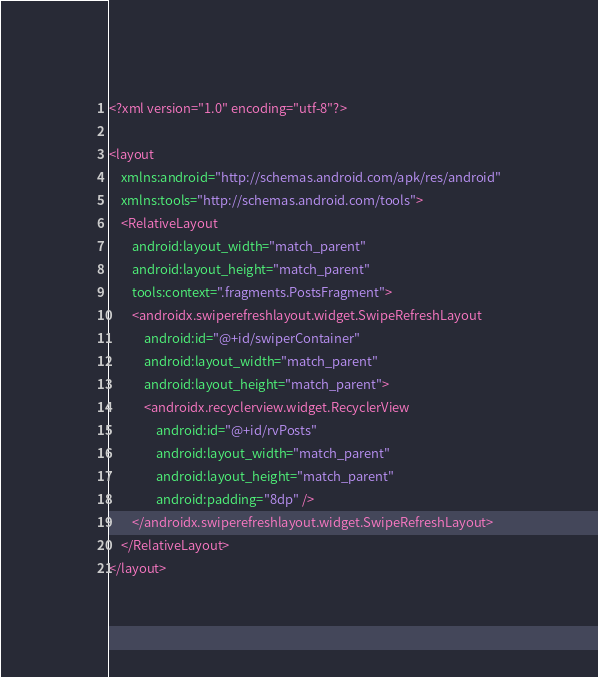Convert code to text. <code><loc_0><loc_0><loc_500><loc_500><_XML_><?xml version="1.0" encoding="utf-8"?>

<layout
    xmlns:android="http://schemas.android.com/apk/res/android"
    xmlns:tools="http://schemas.android.com/tools">
    <RelativeLayout
        android:layout_width="match_parent"
        android:layout_height="match_parent"
        tools:context=".fragments.PostsFragment">
        <androidx.swiperefreshlayout.widget.SwipeRefreshLayout
            android:id="@+id/swiperContainer"
            android:layout_width="match_parent"
            android:layout_height="match_parent">
            <androidx.recyclerview.widget.RecyclerView
                android:id="@+id/rvPosts"
                android:layout_width="match_parent"
                android:layout_height="match_parent"
                android:padding="8dp" />
        </androidx.swiperefreshlayout.widget.SwipeRefreshLayout>
    </RelativeLayout>
</layout>

</code> 